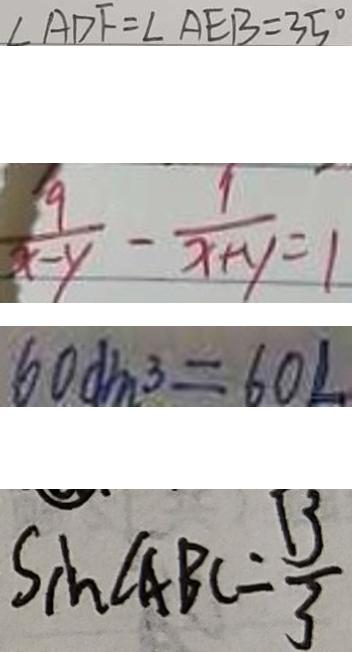Convert formula to latex. <formula><loc_0><loc_0><loc_500><loc_500>\angle A D F = \angle A E B = 3 5 ^ { \circ } 
 \frac { 9 } { x - y } - \frac { 1 } { x + y } = 1 
 6 0 d m ^ { 3 } = 6 0 L 
 \sin \angle A B C = \frac { 1 3 } { 3 }</formula> 